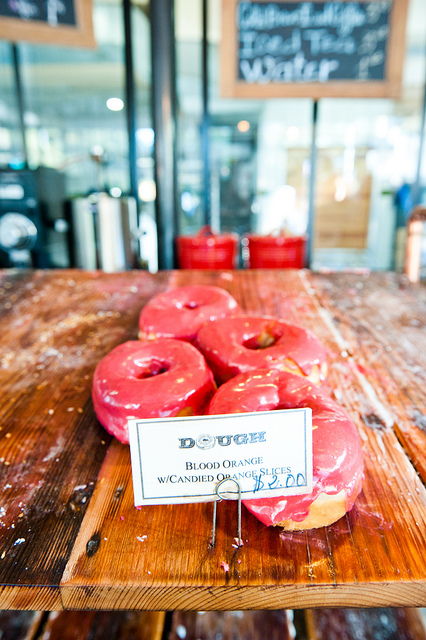Identify the text contained in this image. DOUGH ORANGE BLOOD CANDIED water 2.00 ORANGE w 